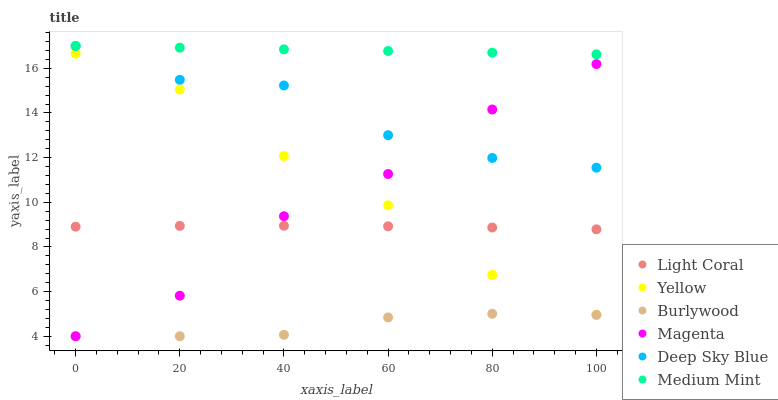Does Burlywood have the minimum area under the curve?
Answer yes or no. Yes. Does Medium Mint have the maximum area under the curve?
Answer yes or no. Yes. Does Yellow have the minimum area under the curve?
Answer yes or no. No. Does Yellow have the maximum area under the curve?
Answer yes or no. No. Is Medium Mint the smoothest?
Answer yes or no. Yes. Is Magenta the roughest?
Answer yes or no. Yes. Is Burlywood the smoothest?
Answer yes or no. No. Is Burlywood the roughest?
Answer yes or no. No. Does Burlywood have the lowest value?
Answer yes or no. Yes. Does Yellow have the lowest value?
Answer yes or no. No. Does Deep Sky Blue have the highest value?
Answer yes or no. Yes. Does Yellow have the highest value?
Answer yes or no. No. Is Burlywood less than Deep Sky Blue?
Answer yes or no. Yes. Is Light Coral greater than Burlywood?
Answer yes or no. Yes. Does Magenta intersect Burlywood?
Answer yes or no. Yes. Is Magenta less than Burlywood?
Answer yes or no. No. Is Magenta greater than Burlywood?
Answer yes or no. No. Does Burlywood intersect Deep Sky Blue?
Answer yes or no. No. 